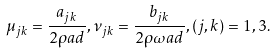<formula> <loc_0><loc_0><loc_500><loc_500>\mu _ { j k } = \frac { a _ { j k } } { 2 \rho a d } , \nu _ { j k } = \frac { b _ { j k } } { 2 \rho \omega a d } , ( j , k ) = 1 , 3 .</formula> 